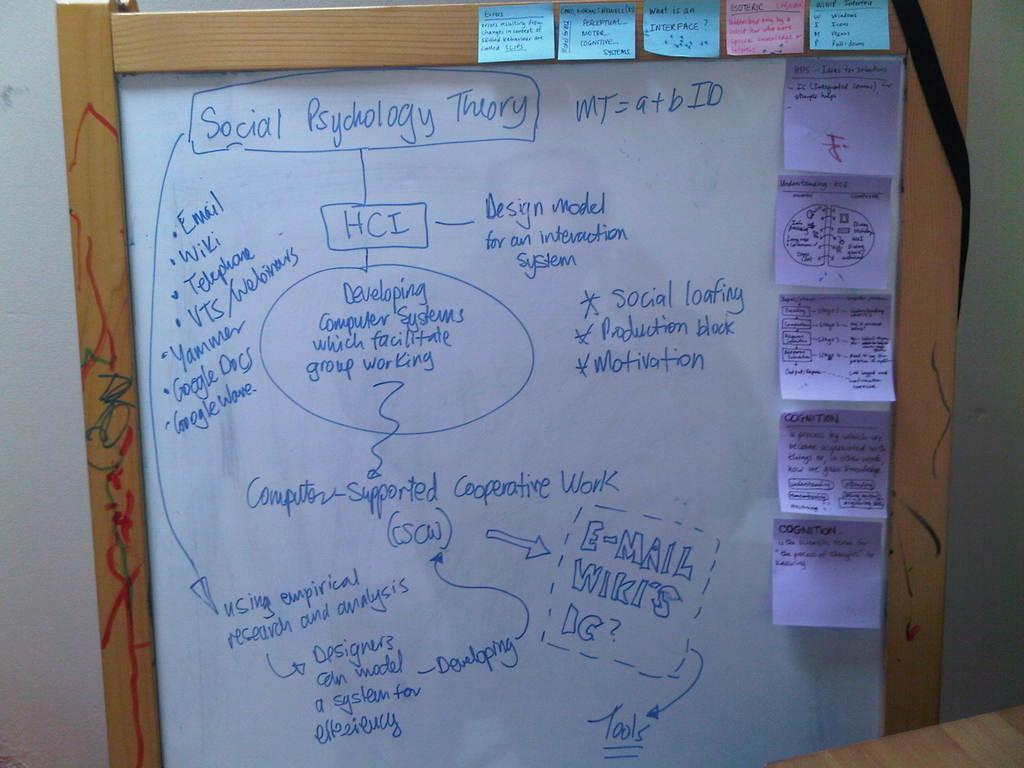<image>
Describe the image concisely. White board with sticky notes and Social Psychology Theory details 